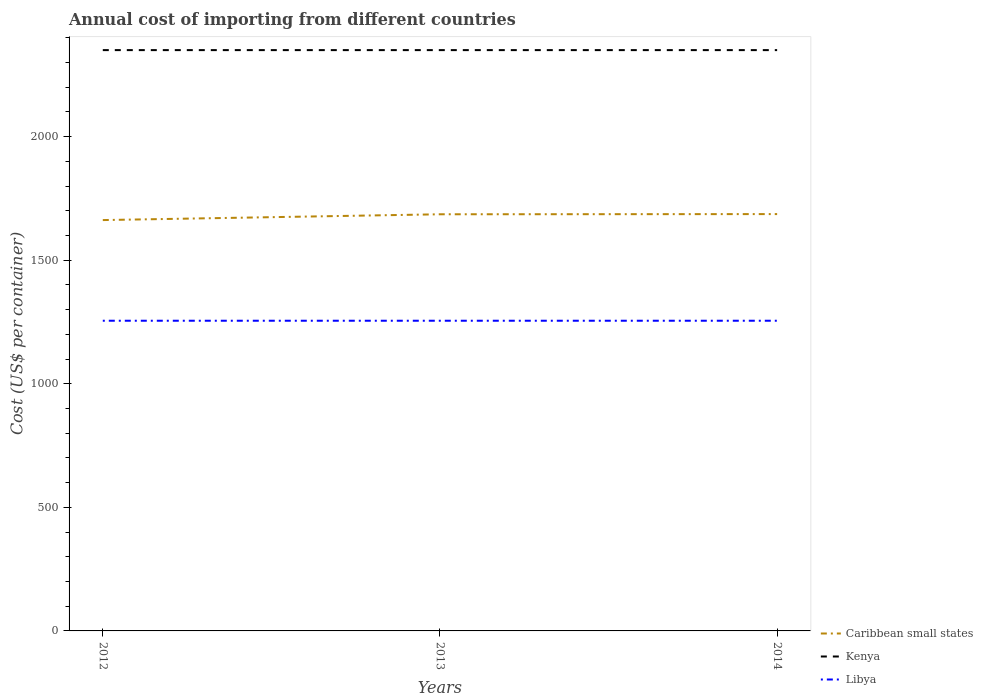How many different coloured lines are there?
Your response must be concise. 3. Is the number of lines equal to the number of legend labels?
Your answer should be very brief. Yes. Across all years, what is the maximum total annual cost of importing in Libya?
Your response must be concise. 1255. In which year was the total annual cost of importing in Kenya maximum?
Offer a terse response. 2012. What is the total total annual cost of importing in Caribbean small states in the graph?
Provide a succinct answer. -0.77. What is the difference between the highest and the second highest total annual cost of importing in Libya?
Provide a succinct answer. 0. Is the total annual cost of importing in Kenya strictly greater than the total annual cost of importing in Caribbean small states over the years?
Offer a terse response. No. How many lines are there?
Give a very brief answer. 3. What is the title of the graph?
Your response must be concise. Annual cost of importing from different countries. What is the label or title of the Y-axis?
Make the answer very short. Cost (US$ per container). What is the Cost (US$ per container) of Caribbean small states in 2012?
Your response must be concise. 1662.31. What is the Cost (US$ per container) in Kenya in 2012?
Ensure brevity in your answer.  2350. What is the Cost (US$ per container) in Libya in 2012?
Make the answer very short. 1255. What is the Cost (US$ per container) in Caribbean small states in 2013?
Your answer should be very brief. 1685.77. What is the Cost (US$ per container) of Kenya in 2013?
Keep it short and to the point. 2350. What is the Cost (US$ per container) in Libya in 2013?
Make the answer very short. 1255. What is the Cost (US$ per container) in Caribbean small states in 2014?
Make the answer very short. 1686.54. What is the Cost (US$ per container) of Kenya in 2014?
Your response must be concise. 2350. What is the Cost (US$ per container) in Libya in 2014?
Your answer should be compact. 1255. Across all years, what is the maximum Cost (US$ per container) of Caribbean small states?
Ensure brevity in your answer.  1686.54. Across all years, what is the maximum Cost (US$ per container) of Kenya?
Your answer should be very brief. 2350. Across all years, what is the maximum Cost (US$ per container) in Libya?
Your answer should be very brief. 1255. Across all years, what is the minimum Cost (US$ per container) in Caribbean small states?
Your answer should be compact. 1662.31. Across all years, what is the minimum Cost (US$ per container) of Kenya?
Provide a succinct answer. 2350. Across all years, what is the minimum Cost (US$ per container) of Libya?
Ensure brevity in your answer.  1255. What is the total Cost (US$ per container) of Caribbean small states in the graph?
Your answer should be very brief. 5034.62. What is the total Cost (US$ per container) of Kenya in the graph?
Ensure brevity in your answer.  7050. What is the total Cost (US$ per container) of Libya in the graph?
Your response must be concise. 3765. What is the difference between the Cost (US$ per container) of Caribbean small states in 2012 and that in 2013?
Your answer should be very brief. -23.46. What is the difference between the Cost (US$ per container) in Libya in 2012 and that in 2013?
Ensure brevity in your answer.  0. What is the difference between the Cost (US$ per container) of Caribbean small states in 2012 and that in 2014?
Keep it short and to the point. -24.23. What is the difference between the Cost (US$ per container) of Caribbean small states in 2013 and that in 2014?
Ensure brevity in your answer.  -0.77. What is the difference between the Cost (US$ per container) of Kenya in 2013 and that in 2014?
Keep it short and to the point. 0. What is the difference between the Cost (US$ per container) in Libya in 2013 and that in 2014?
Offer a very short reply. 0. What is the difference between the Cost (US$ per container) in Caribbean small states in 2012 and the Cost (US$ per container) in Kenya in 2013?
Provide a succinct answer. -687.69. What is the difference between the Cost (US$ per container) in Caribbean small states in 2012 and the Cost (US$ per container) in Libya in 2013?
Your response must be concise. 407.31. What is the difference between the Cost (US$ per container) of Kenya in 2012 and the Cost (US$ per container) of Libya in 2013?
Provide a succinct answer. 1095. What is the difference between the Cost (US$ per container) of Caribbean small states in 2012 and the Cost (US$ per container) of Kenya in 2014?
Provide a short and direct response. -687.69. What is the difference between the Cost (US$ per container) of Caribbean small states in 2012 and the Cost (US$ per container) of Libya in 2014?
Your response must be concise. 407.31. What is the difference between the Cost (US$ per container) in Kenya in 2012 and the Cost (US$ per container) in Libya in 2014?
Keep it short and to the point. 1095. What is the difference between the Cost (US$ per container) of Caribbean small states in 2013 and the Cost (US$ per container) of Kenya in 2014?
Provide a short and direct response. -664.23. What is the difference between the Cost (US$ per container) in Caribbean small states in 2013 and the Cost (US$ per container) in Libya in 2014?
Give a very brief answer. 430.77. What is the difference between the Cost (US$ per container) of Kenya in 2013 and the Cost (US$ per container) of Libya in 2014?
Offer a terse response. 1095. What is the average Cost (US$ per container) of Caribbean small states per year?
Your response must be concise. 1678.21. What is the average Cost (US$ per container) in Kenya per year?
Offer a terse response. 2350. What is the average Cost (US$ per container) in Libya per year?
Your answer should be compact. 1255. In the year 2012, what is the difference between the Cost (US$ per container) in Caribbean small states and Cost (US$ per container) in Kenya?
Give a very brief answer. -687.69. In the year 2012, what is the difference between the Cost (US$ per container) in Caribbean small states and Cost (US$ per container) in Libya?
Give a very brief answer. 407.31. In the year 2012, what is the difference between the Cost (US$ per container) of Kenya and Cost (US$ per container) of Libya?
Your response must be concise. 1095. In the year 2013, what is the difference between the Cost (US$ per container) in Caribbean small states and Cost (US$ per container) in Kenya?
Provide a succinct answer. -664.23. In the year 2013, what is the difference between the Cost (US$ per container) of Caribbean small states and Cost (US$ per container) of Libya?
Keep it short and to the point. 430.77. In the year 2013, what is the difference between the Cost (US$ per container) in Kenya and Cost (US$ per container) in Libya?
Your answer should be compact. 1095. In the year 2014, what is the difference between the Cost (US$ per container) of Caribbean small states and Cost (US$ per container) of Kenya?
Offer a terse response. -663.46. In the year 2014, what is the difference between the Cost (US$ per container) of Caribbean small states and Cost (US$ per container) of Libya?
Provide a succinct answer. 431.54. In the year 2014, what is the difference between the Cost (US$ per container) in Kenya and Cost (US$ per container) in Libya?
Give a very brief answer. 1095. What is the ratio of the Cost (US$ per container) in Caribbean small states in 2012 to that in 2013?
Make the answer very short. 0.99. What is the ratio of the Cost (US$ per container) of Caribbean small states in 2012 to that in 2014?
Offer a very short reply. 0.99. What is the ratio of the Cost (US$ per container) in Libya in 2012 to that in 2014?
Offer a terse response. 1. What is the ratio of the Cost (US$ per container) of Kenya in 2013 to that in 2014?
Your answer should be compact. 1. What is the ratio of the Cost (US$ per container) in Libya in 2013 to that in 2014?
Offer a terse response. 1. What is the difference between the highest and the second highest Cost (US$ per container) of Caribbean small states?
Make the answer very short. 0.77. What is the difference between the highest and the lowest Cost (US$ per container) of Caribbean small states?
Make the answer very short. 24.23. What is the difference between the highest and the lowest Cost (US$ per container) of Kenya?
Keep it short and to the point. 0. What is the difference between the highest and the lowest Cost (US$ per container) of Libya?
Your answer should be compact. 0. 